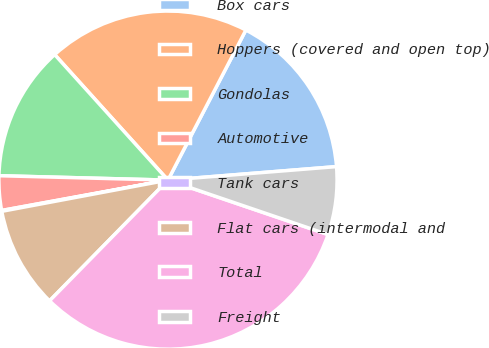Convert chart to OTSL. <chart><loc_0><loc_0><loc_500><loc_500><pie_chart><fcel>Box cars<fcel>Hoppers (covered and open top)<fcel>Gondolas<fcel>Automotive<fcel>Tank cars<fcel>Flat cars (intermodal and<fcel>Total<fcel>Freight<nl><fcel>16.11%<fcel>19.31%<fcel>12.9%<fcel>3.29%<fcel>0.08%<fcel>9.7%<fcel>32.13%<fcel>6.49%<nl></chart> 